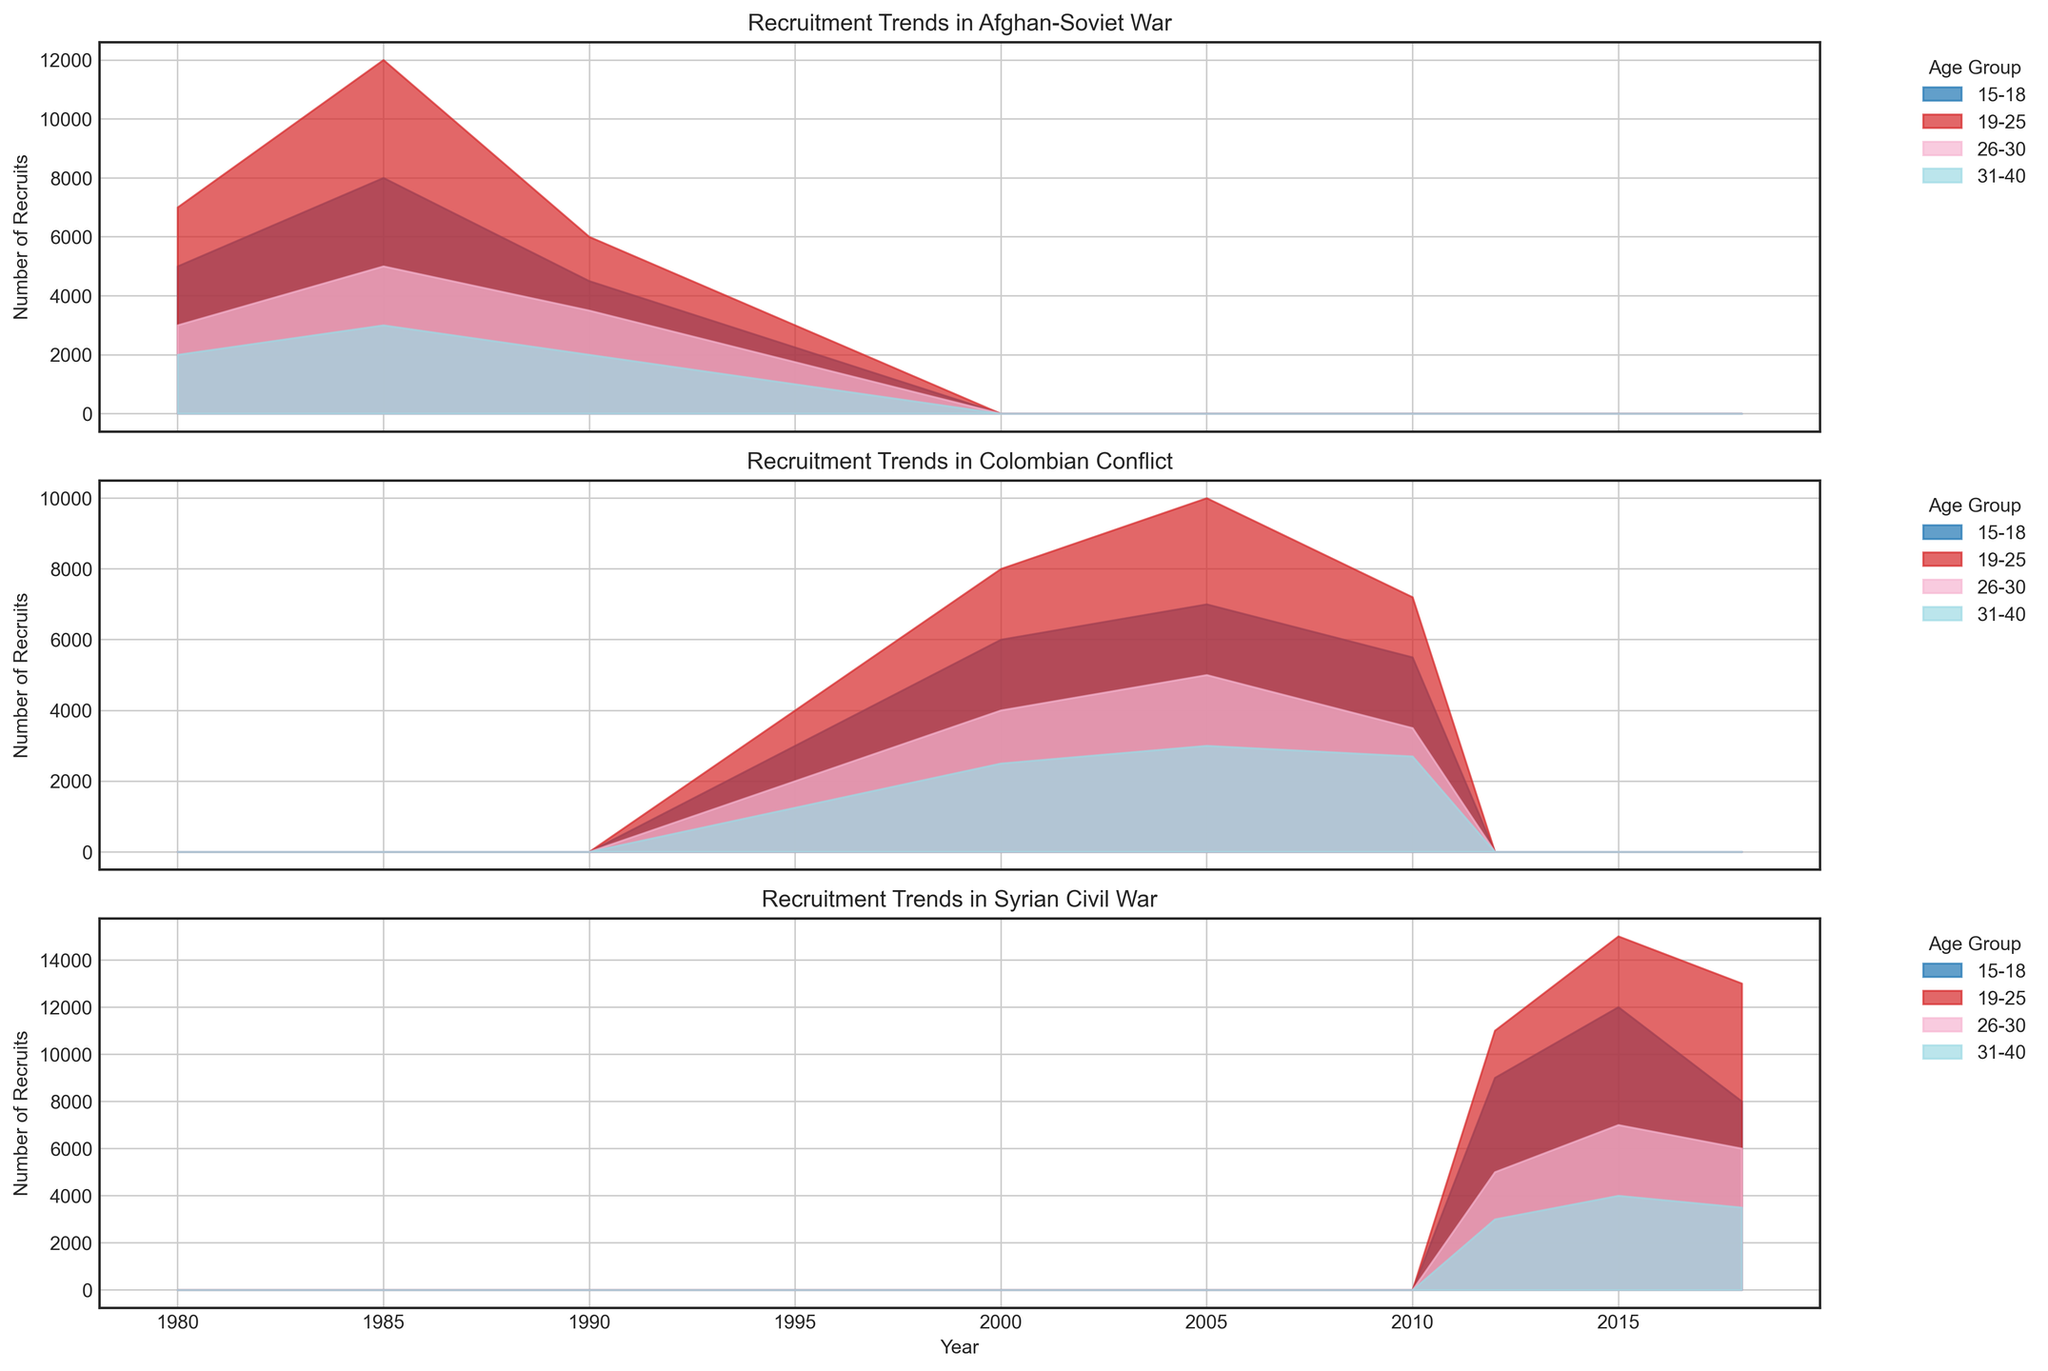Which age group had the highest number of recruits in the Afghan-Soviet War in 1985? The chart for the Afghan-Soviet War in 1985 shows multiple age groups. By examining the filled areas, the 19-25 age group reaches higher values compared to the other age groups, making it the highest.
Answer: 19-25 Did the number of recruits for the 15-18 age group increase or decrease from 1980 to 1985 in the Afghan-Soviet War? By comparing the 15-18 age group's filled area between 1980 and 1985 in the Afghan-Soviet War chart, it is visible that the area grows from 5000 to 8000, indicating an increase.
Answer: Increase How did the recruitment trend of the 26-30 age group change from 2012 to 2018 in the Syrian Civil War? The plot shows that the filled area for the 26-30 age group in the Syrian Civil War rises from 5000 in 2012, goes up to 7000 in 2015, and slightly decreases to 6000 in 2018.
Answer: Increase and then Decrease For the Colombian Conflict in 2005, which age group had the least number of recruits and how many were they approximately? By examining the Colombian Conflict chart for 2005, the 31-40 age group covers the smallest area among the age groups, showing about 3000 recruits.
Answer: 31-40, 3000 Which conflict had the largest overall number of recruits in 1985? By comparing the filled areas for 1985 across different conflicts (in this case, only the Afghan-Soviet War), the Afghan-Soviet War shows substantial filled areas amounting to a total number of recruits.
Answer: Afghan-Soviet War Compare the recruitment numbers of the 19-25 age group in the Colombian Conflict in 2000 and 2010. In the Colombian Conflict chart for the 19-25 age group, the filled area was higher in 2000 with 8000 recruits, whereas in 2010, it decreased to 7200.
Answer: 2000 had more recruits Which age group showed the highest increase in recruitment numbers from 2012 to 2015 in the Syrian Civil War? By observing the Syrian Civil War chart and calculating the difference, the 19-25 age group's filled area went from 11000 in 2012 to 15000 in 2015, indicating an increase of 4000, the highest among the groups.
Answer: 19-25 What was the trend in recruitments for the 31-40 age group during the Colombian Conflict from 2000 to 2010? The 31-40 age group's filled area in the Colombian Conflict chart moves from 2500 in 2000 to 3000 in 2005, then slightly drops to 2700 in 2010, indicating a slight rise, then fall.
Answer: Slight rise, then fall Which age group consistently had the lowest recruitment numbers across all years in the Afghan-Soviet War? Examining the Afghan-Soviet War chart, the 31-40 age group consistently shows the smallest filled areas across all years (1980, 1985, 1990), depicting the lowest recruit numbers.
Answer: 31-40 Calculate the total number of recruits for the 19-25 age group across all three conflicts in the year 2000. Summing up the recruits for the 19-25 age group in 2000 for each conflict (shown in the corresponding charts): Afghan-Soviet War doesn't include 2000, so it is just: Colombian Conflict (8000) + Syrian Civil War (NA) = 8000.
Answer: 8000 